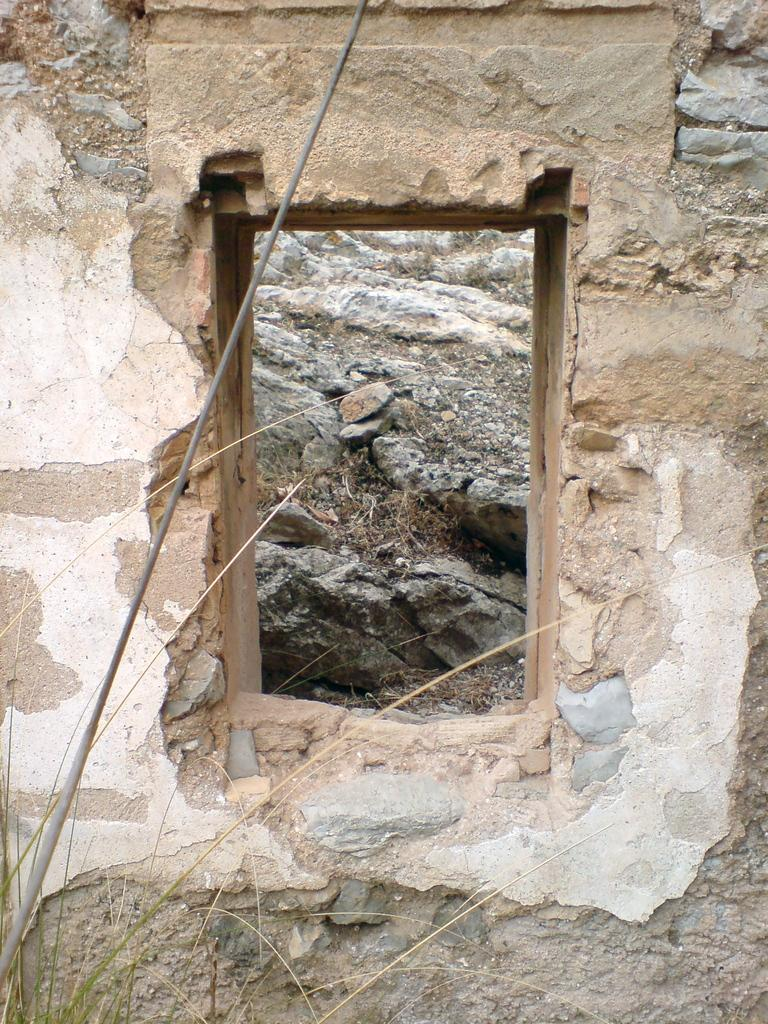What type of window is in the image? There is a wooden window in the image. What is the condition of the wall on which the window is placed? The wooden window is on a broken wall. What type of vegetation can be seen at the bottom of the image? There is grass visible at the bottom of the image. What can be seen through the wooden window? There are stones visible through the window. How many apples are hanging from the wooden window in the image? There are no apples present in the image. Is there a bat flying near the wooden window in the image? There is no bat visible in the image. 